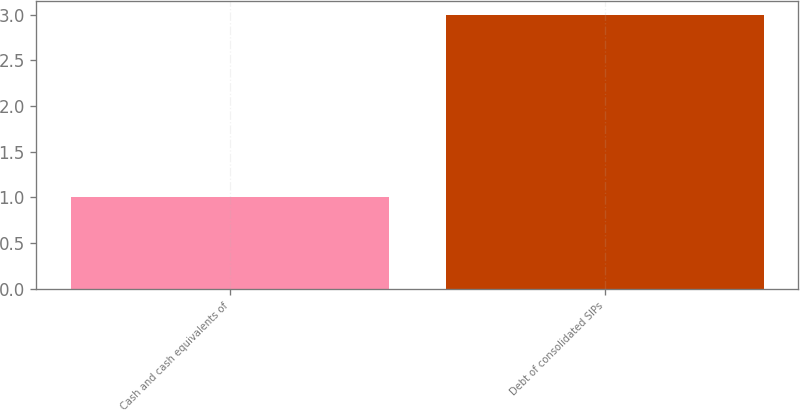Convert chart to OTSL. <chart><loc_0><loc_0><loc_500><loc_500><bar_chart><fcel>Cash and cash equivalents of<fcel>Debt of consolidated SIPs<nl><fcel>1<fcel>3<nl></chart> 